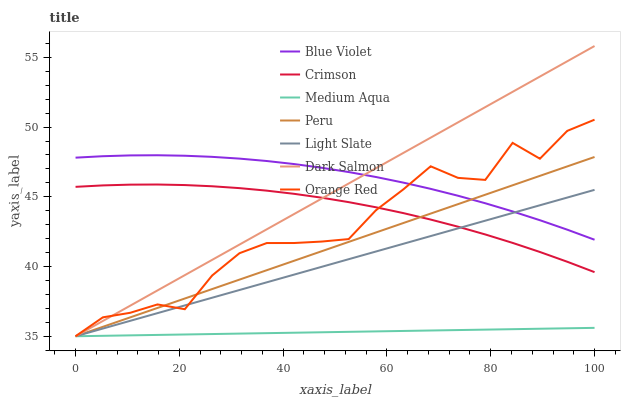Does Medium Aqua have the minimum area under the curve?
Answer yes or no. Yes. Does Blue Violet have the maximum area under the curve?
Answer yes or no. Yes. Does Dark Salmon have the minimum area under the curve?
Answer yes or no. No. Does Dark Salmon have the maximum area under the curve?
Answer yes or no. No. Is Medium Aqua the smoothest?
Answer yes or no. Yes. Is Orange Red the roughest?
Answer yes or no. Yes. Is Dark Salmon the smoothest?
Answer yes or no. No. Is Dark Salmon the roughest?
Answer yes or no. No. Does Light Slate have the lowest value?
Answer yes or no. Yes. Does Crimson have the lowest value?
Answer yes or no. No. Does Dark Salmon have the highest value?
Answer yes or no. Yes. Does Medium Aqua have the highest value?
Answer yes or no. No. Is Medium Aqua less than Crimson?
Answer yes or no. Yes. Is Crimson greater than Medium Aqua?
Answer yes or no. Yes. Does Light Slate intersect Blue Violet?
Answer yes or no. Yes. Is Light Slate less than Blue Violet?
Answer yes or no. No. Is Light Slate greater than Blue Violet?
Answer yes or no. No. Does Medium Aqua intersect Crimson?
Answer yes or no. No. 